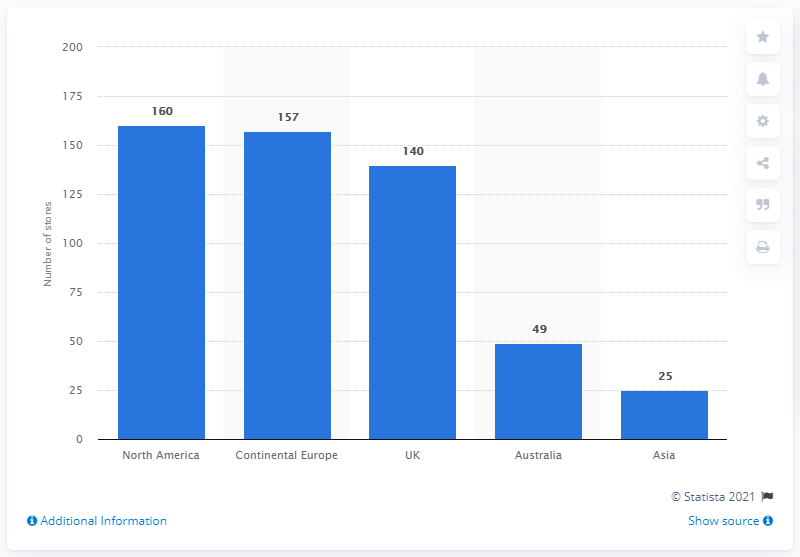Point out several critical features in this image. As of May 31, 2020, Games Workshop had 140 stores in the United Kingdom. 